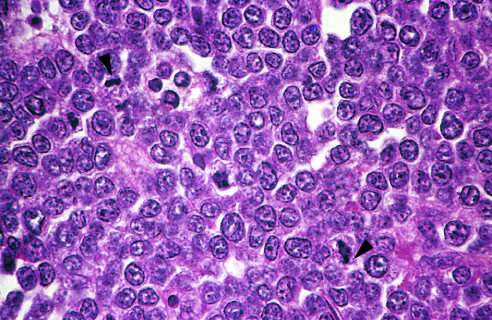how are the tumor cells and their nuclei?
Answer the question using a single word or phrase. Fairly uniform 